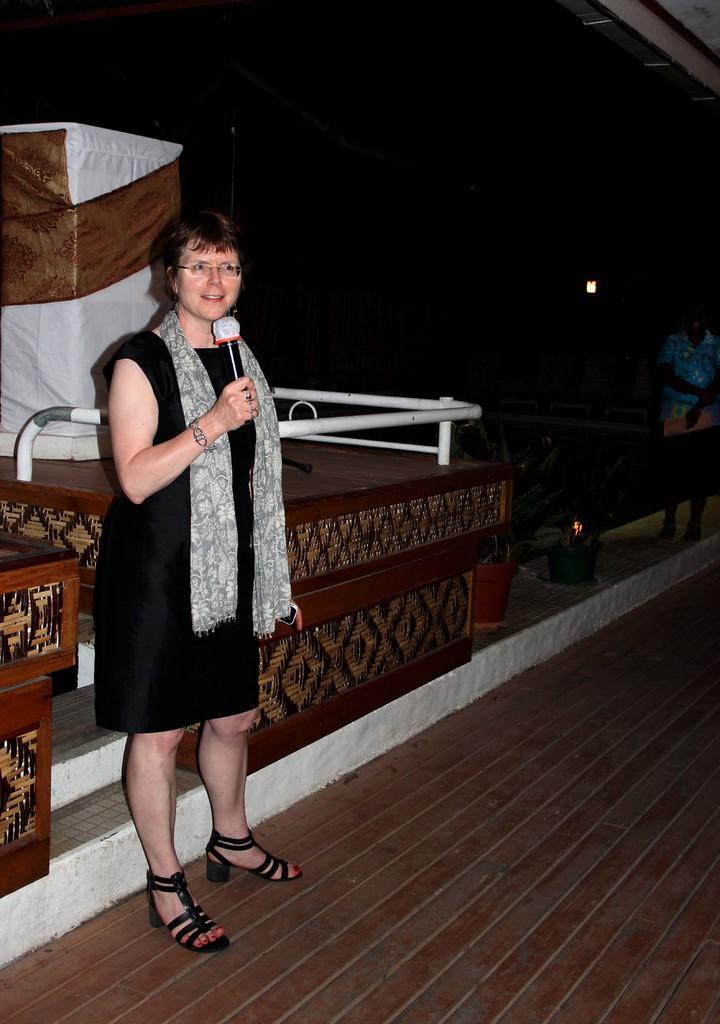Could you give a brief overview of what you see in this image? In this image, I can see a woman standing on the floor and holding a mike. On the right side of the image, there is another person standing and holding an object. I can see flower pots with plants. Behind the woman, there is an object. The background is dark. 